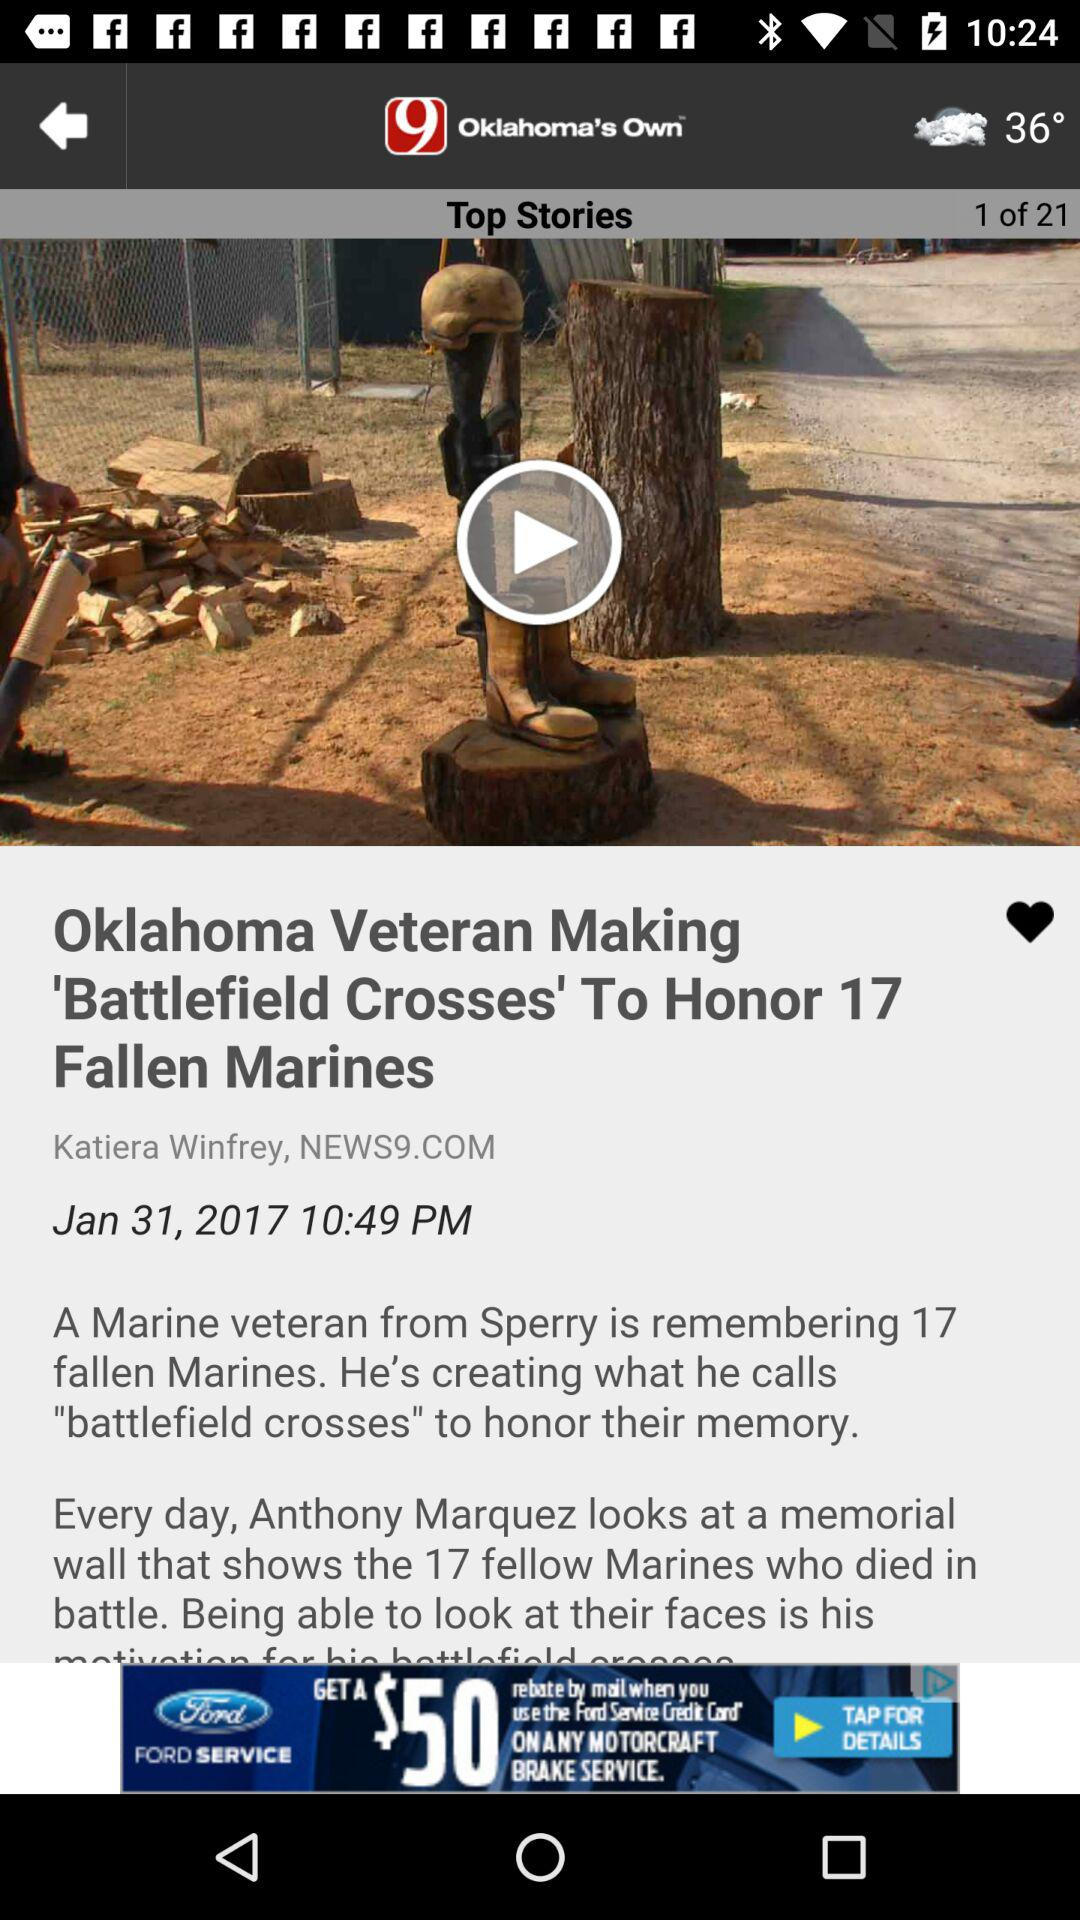What is the temperature? The temperature is 36°. 